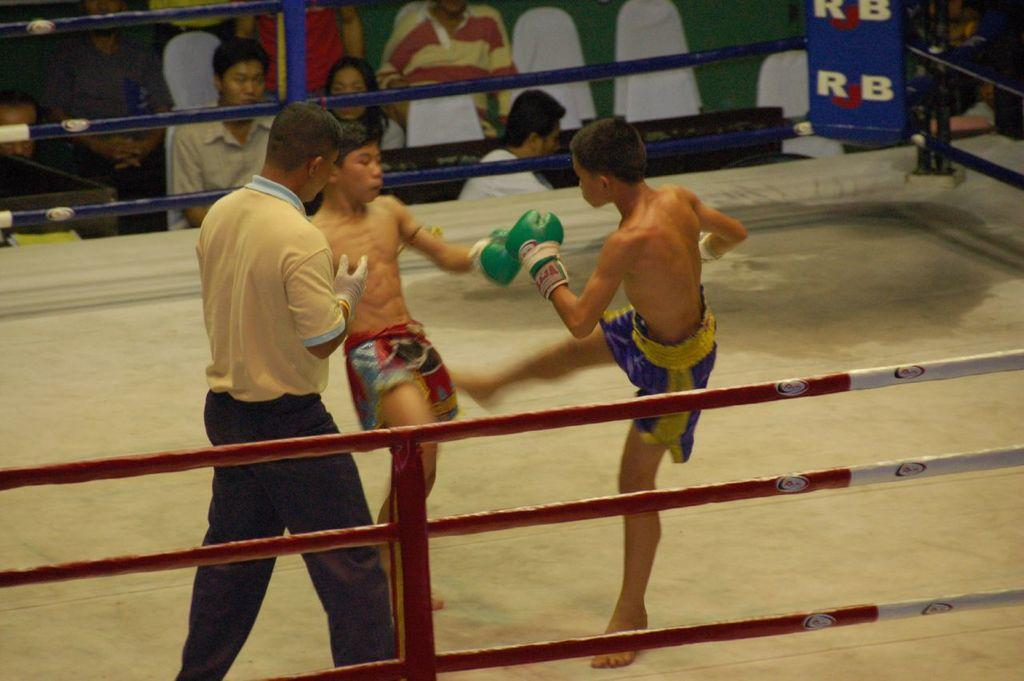<image>
Share a concise interpretation of the image provided. Two young boys face each other in an RJB boxing ring 